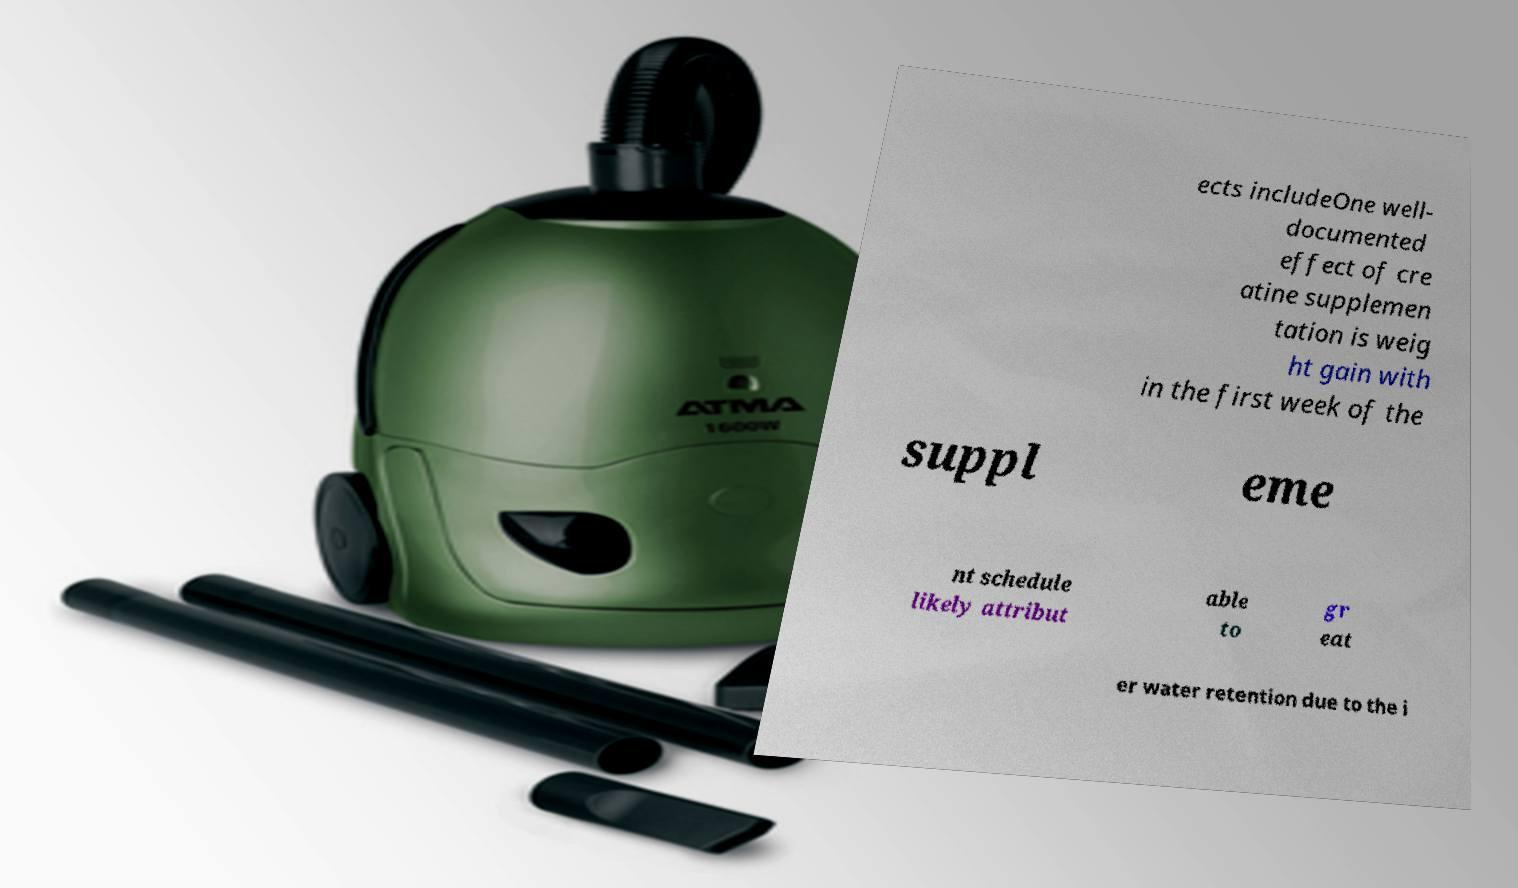What messages or text are displayed in this image? I need them in a readable, typed format. ects includeOne well- documented effect of cre atine supplemen tation is weig ht gain with in the first week of the suppl eme nt schedule likely attribut able to gr eat er water retention due to the i 